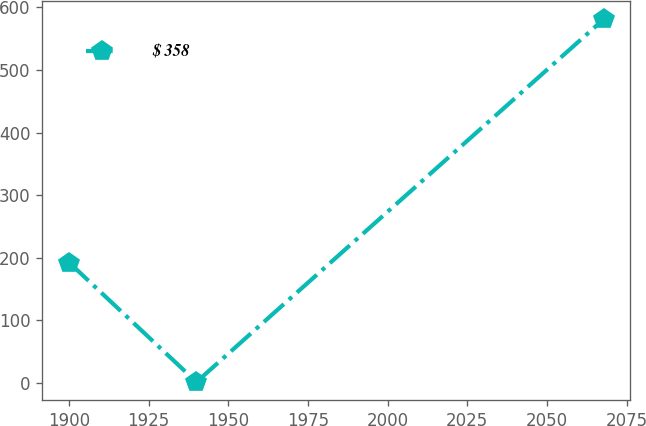Convert chart. <chart><loc_0><loc_0><loc_500><loc_500><line_chart><ecel><fcel>$ 358<nl><fcel>1900.07<fcel>192.54<nl><fcel>1940.02<fcel>1.67<nl><fcel>2067.77<fcel>581.11<nl></chart> 